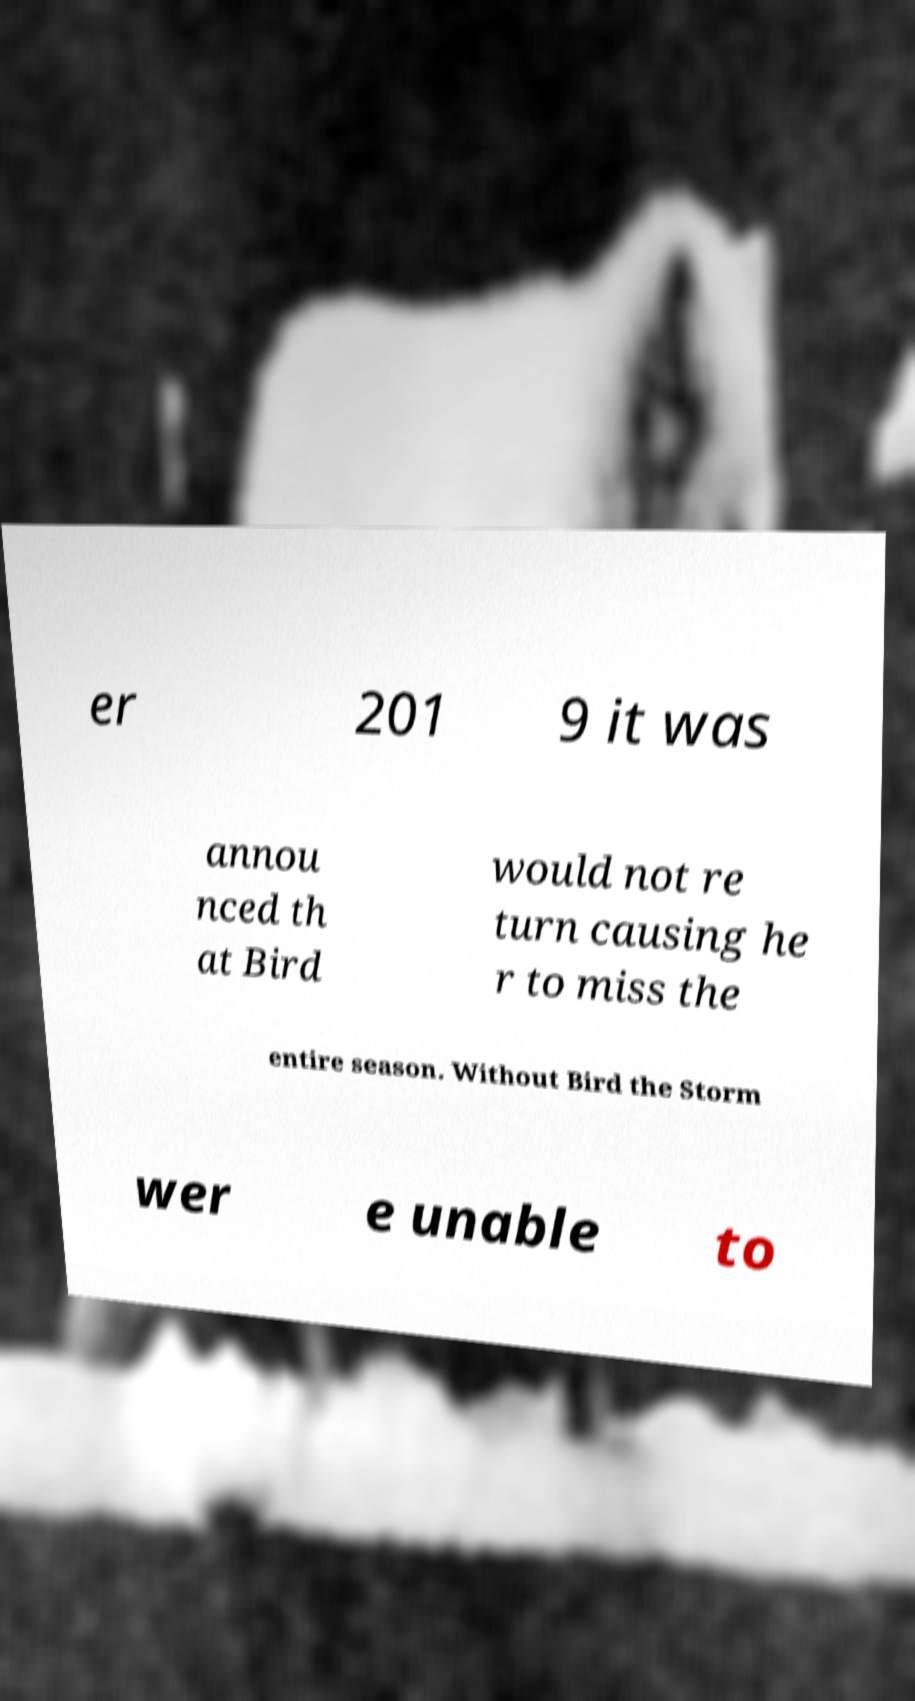Could you assist in decoding the text presented in this image and type it out clearly? er 201 9 it was annou nced th at Bird would not re turn causing he r to miss the entire season. Without Bird the Storm wer e unable to 